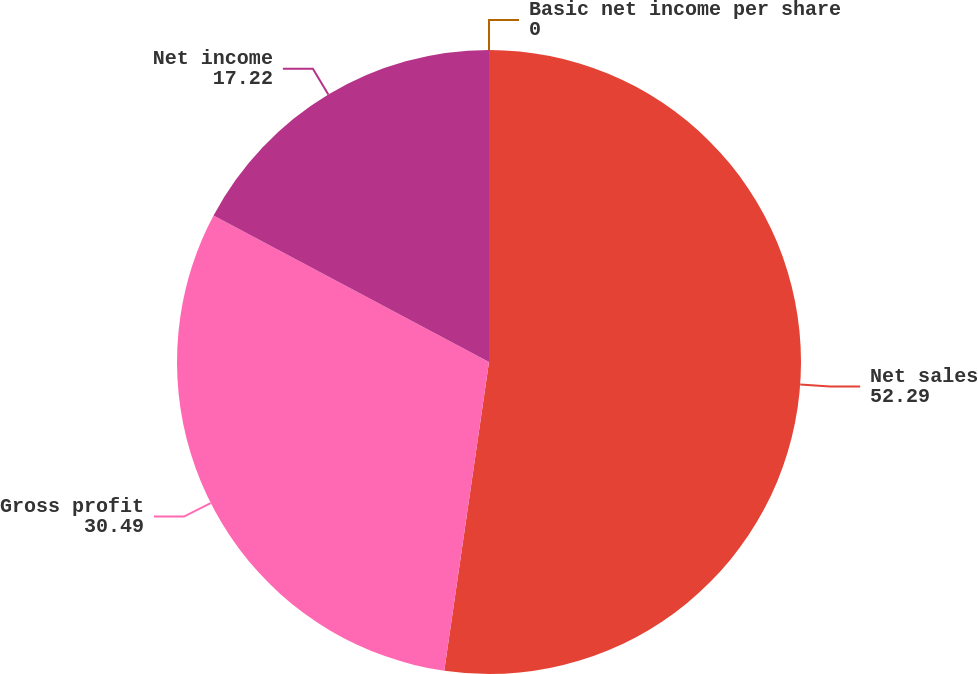Convert chart to OTSL. <chart><loc_0><loc_0><loc_500><loc_500><pie_chart><fcel>Net sales<fcel>Gross profit<fcel>Net income<fcel>Basic net income per share<nl><fcel>52.29%<fcel>30.49%<fcel>17.22%<fcel>0.0%<nl></chart> 